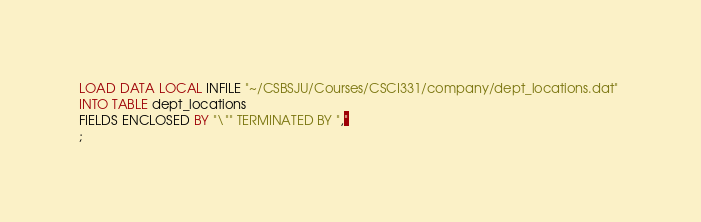Convert code to text. <code><loc_0><loc_0><loc_500><loc_500><_SQL_>LOAD DATA LOCAL INFILE "~/CSBSJU/Courses/CSCI331/company/dept_locations.dat" 
INTO TABLE dept_locations 
FIELDS ENCLOSED BY "\"" TERMINATED BY ","
;
</code> 